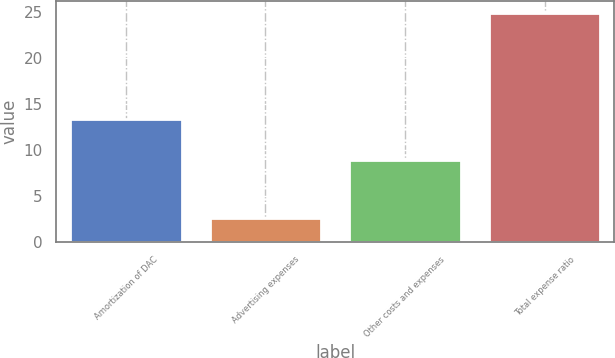Convert chart. <chart><loc_0><loc_0><loc_500><loc_500><bar_chart><fcel>Amortization of DAC<fcel>Advertising expenses<fcel>Other costs and expenses<fcel>Total expense ratio<nl><fcel>13.3<fcel>2.6<fcel>8.9<fcel>24.9<nl></chart> 